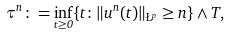<formula> <loc_0><loc_0><loc_500><loc_500>\tau ^ { n } \colon = \inf _ { t \geq 0 } \{ t \colon \| u ^ { n } ( t ) \| _ { \L ^ { p } } \geq n \} \wedge T ,</formula> 